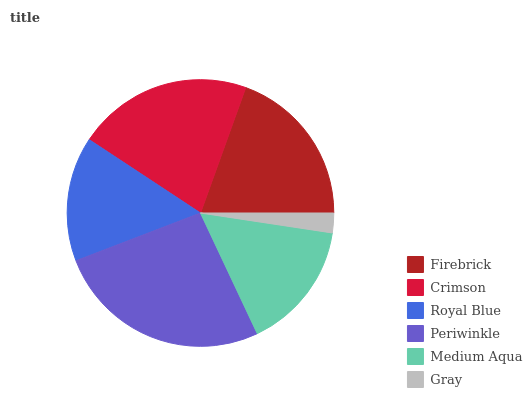Is Gray the minimum?
Answer yes or no. Yes. Is Periwinkle the maximum?
Answer yes or no. Yes. Is Crimson the minimum?
Answer yes or no. No. Is Crimson the maximum?
Answer yes or no. No. Is Crimson greater than Firebrick?
Answer yes or no. Yes. Is Firebrick less than Crimson?
Answer yes or no. Yes. Is Firebrick greater than Crimson?
Answer yes or no. No. Is Crimson less than Firebrick?
Answer yes or no. No. Is Firebrick the high median?
Answer yes or no. Yes. Is Medium Aqua the low median?
Answer yes or no. Yes. Is Crimson the high median?
Answer yes or no. No. Is Gray the low median?
Answer yes or no. No. 